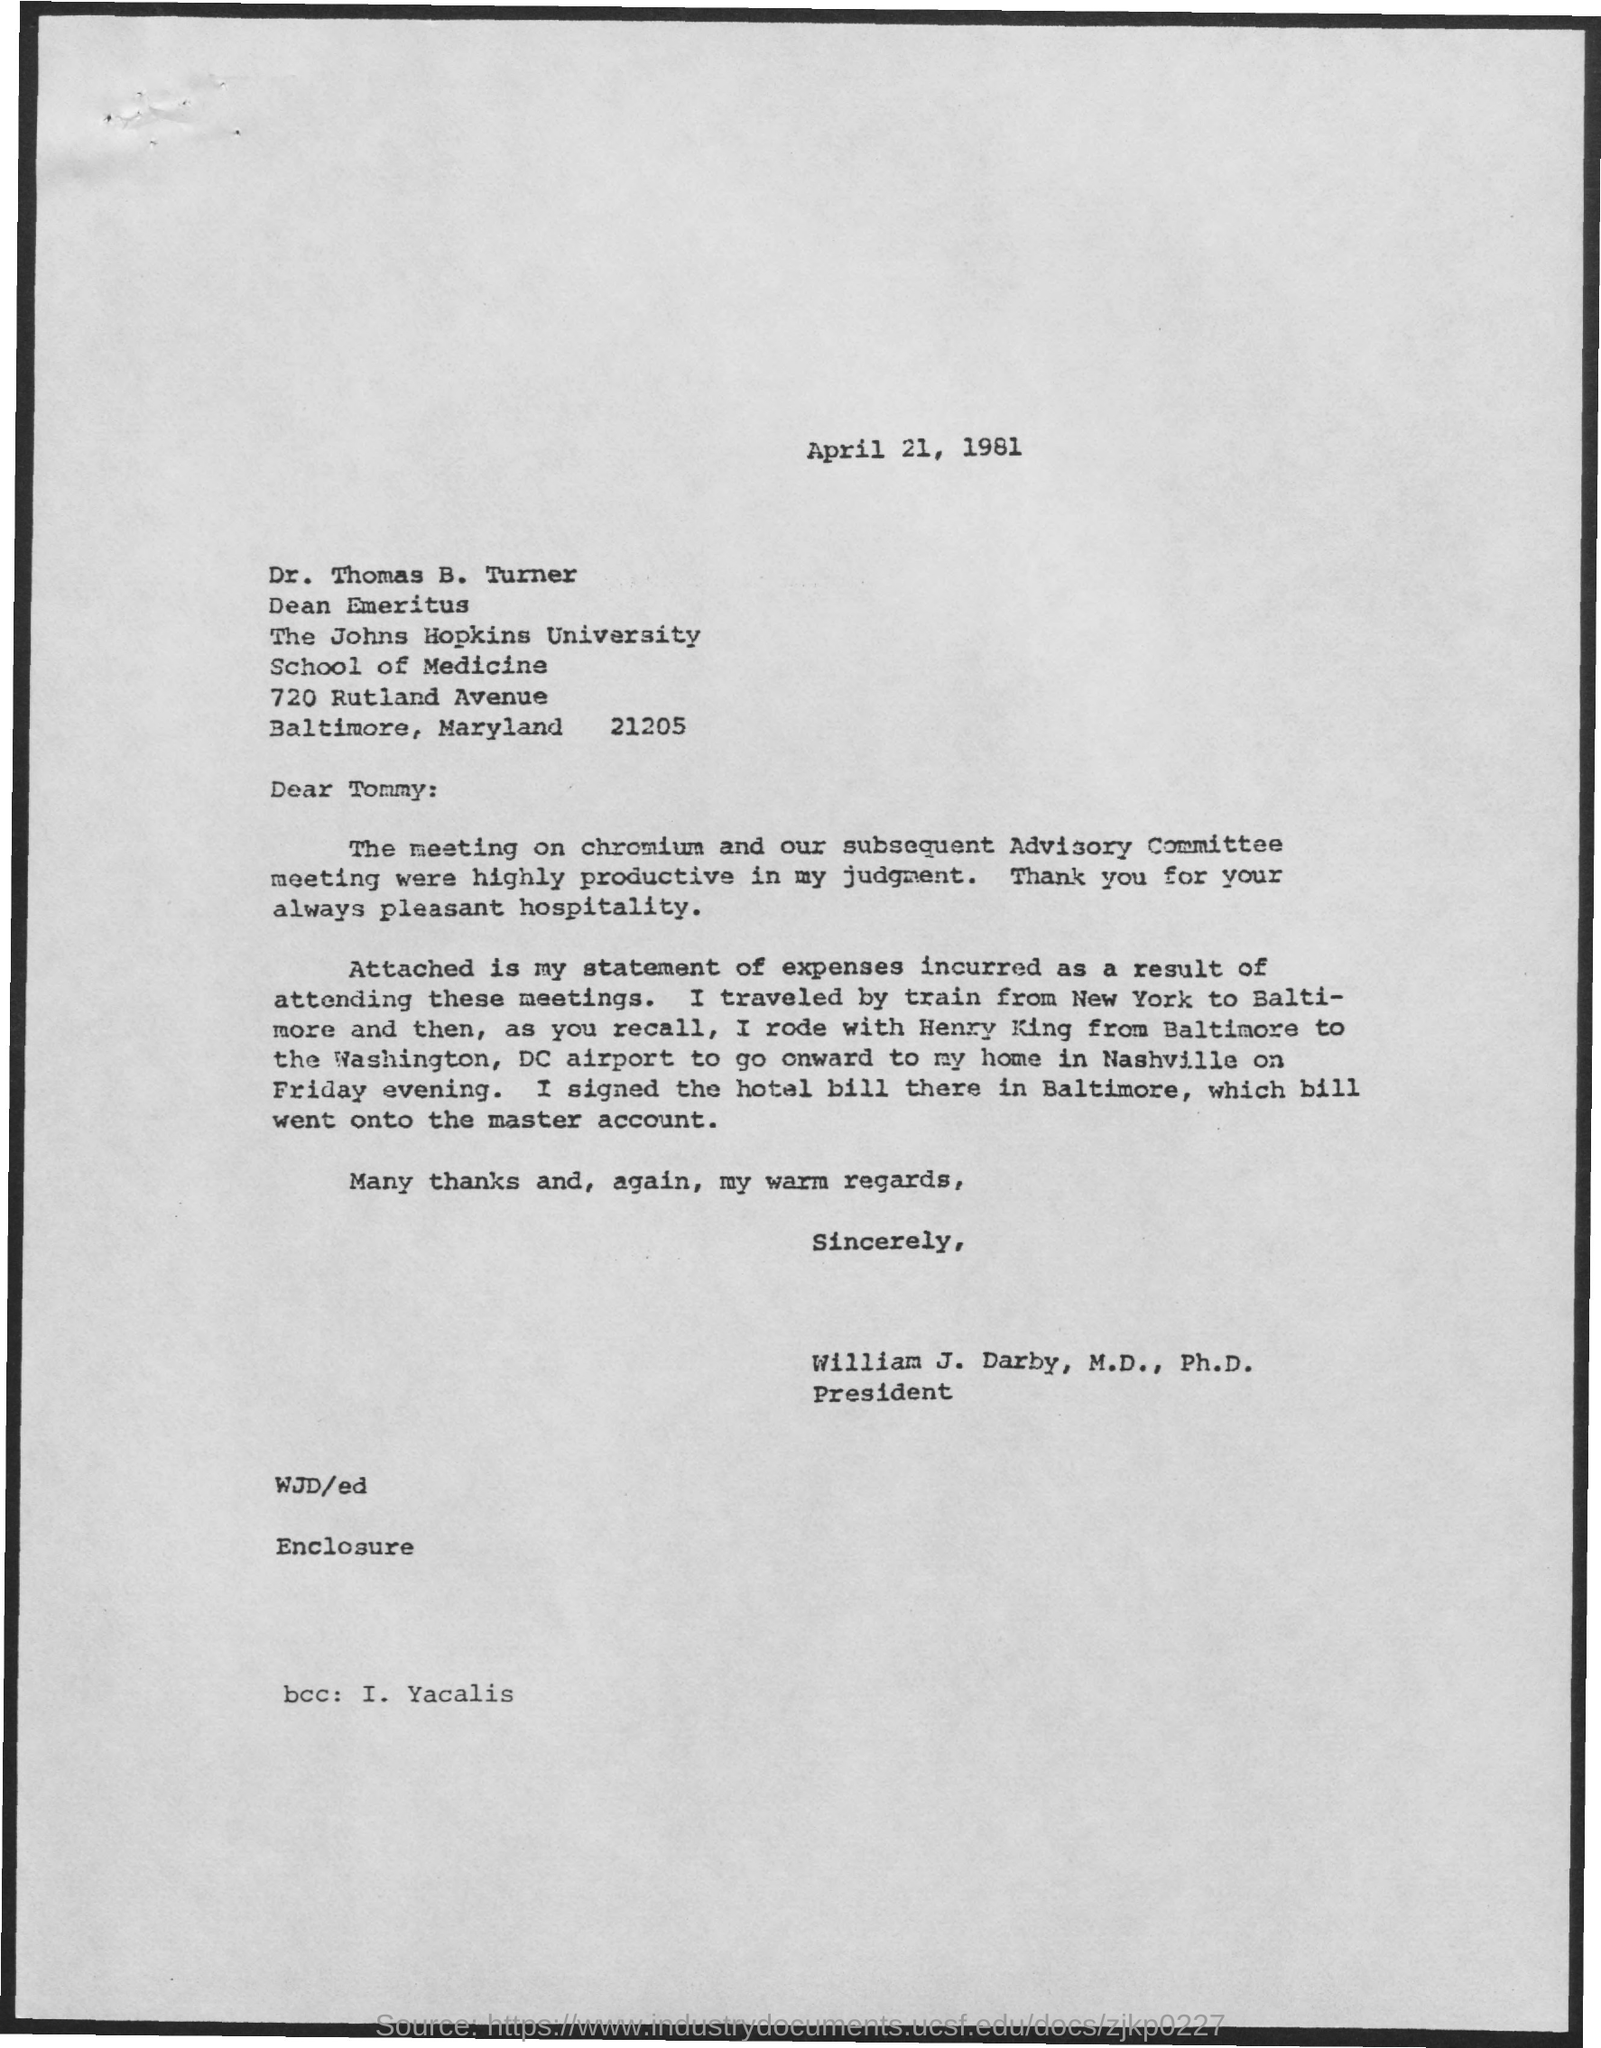Draw attention to some important aspects in this diagram. The date mentioned in this letter is April 21, 1981. The sender of this letter is William J. Darby, M.D., Ph.D. The recipient of this letter is marked in the BCC field. The name Yacalis is mentioned. William J. Darby, M.D., Ph.D., holds the designation of President. 